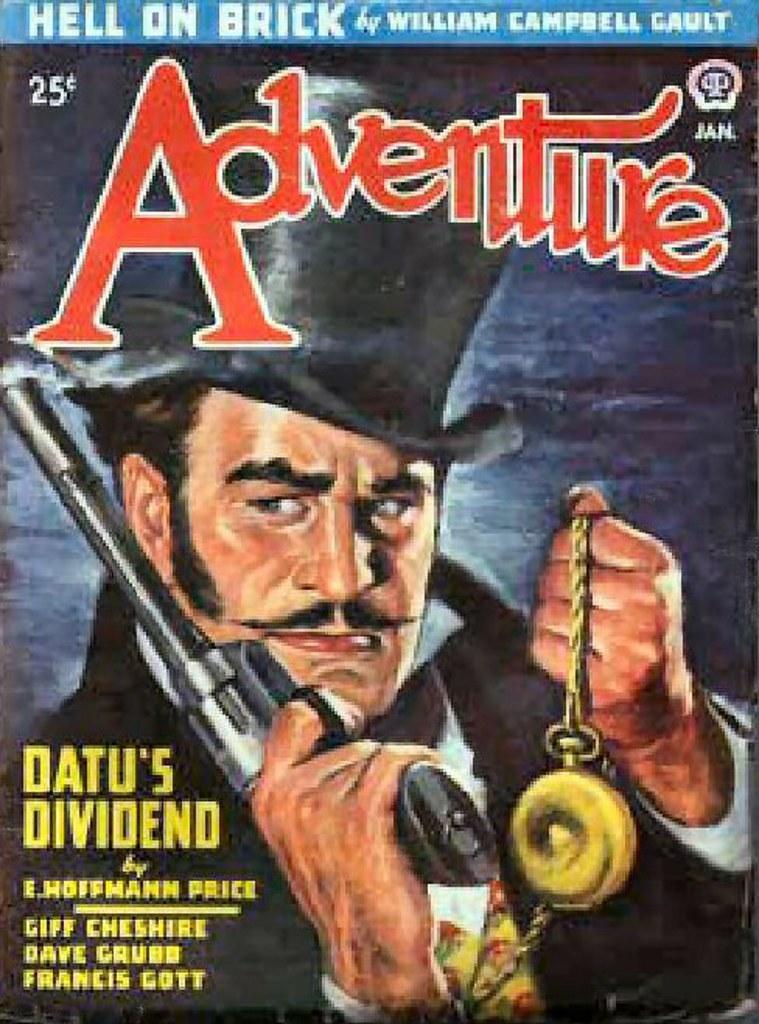Can you describe this image briefly? In this picture we can see poster, in this poster we can see a man holding a gun and an object and we can see some text. 